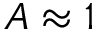Convert formula to latex. <formula><loc_0><loc_0><loc_500><loc_500>A \approx 1</formula> 